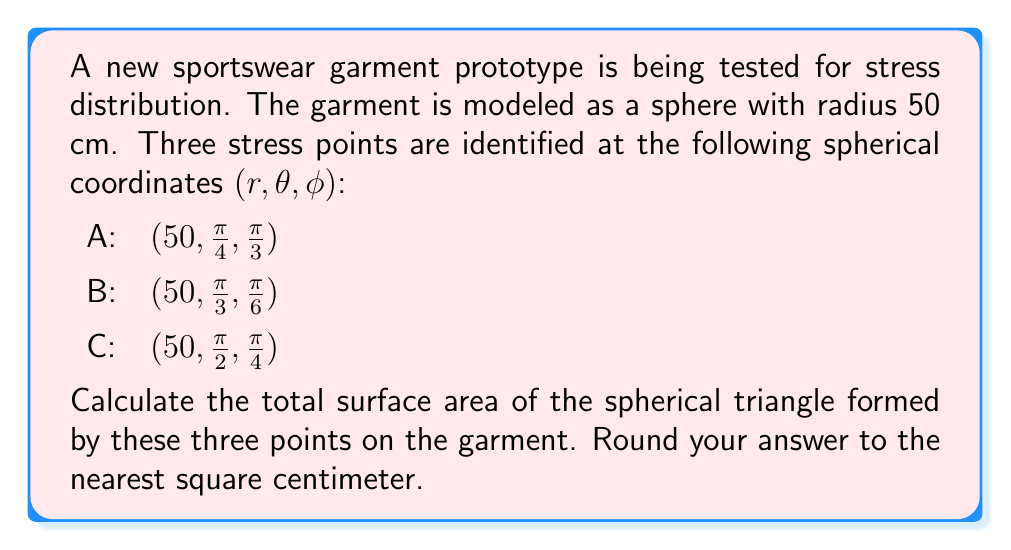Show me your answer to this math problem. To solve this problem, we'll use the following steps:

1) First, we need to calculate the angles between the points on the sphere's surface. We can do this using the spherical law of cosines:

   $$\cos(c) = \sin(a)\sin(b)\cos(C) + \cos(a)\cos(b)$$

   where $a$, $b$, and $c$ are the great circle distances between the points, and $C$ is the angle between $a$ and $b$ at the pole.

2) We can calculate $\cos(C)$ for each pair of points using:

   $$\cos(C) = \frac{\cos(c) - \cos(a)\cos(b)}{\sin(a)\sin(b)}$$

3) Once we have the angles, we can use the spherical excess formula to calculate the area:

   $$A = R^2(A + B + C - \pi)$$

   where $A$, $B$, and $C$ are the angles of the spherical triangle, and $R$ is the radius of the sphere.

4) Let's calculate the cosines of the great circle distances:

   $$\cos(AB) = \sin(\frac{\pi}{4})\sin(\frac{\pi}{3})\cos(\frac{\pi}{3}-\frac{\pi}{6}) + \cos(\frac{\pi}{4})\cos(\frac{\pi}{3})$$
   $$\cos(BC) = \sin(\frac{\pi}{3})\sin(\frac{\pi}{2})\cos(\frac{\pi}{6}-\frac{\pi}{4}) + \cos(\frac{\pi}{3})\cos(\frac{\pi}{2})$$
   $$\cos(AC) = \sin(\frac{\pi}{4})\sin(\frac{\pi}{2})\cos(\frac{\pi}{3}-\frac{\pi}{4}) + \cos(\frac{\pi}{4})\cos(\frac{\pi}{2})$$

5) Now we can calculate the angles:

   $$A = \arccos(\frac{\cos(BC) - \cos(AB)\cos(AC)}{\sin(AB)\sin(AC)})$$
   $$B = \arccos(\frac{\cos(AC) - \cos(AB)\cos(BC)}{\sin(AB)\sin(BC)})$$
   $$C = \arccos(\frac{\cos(AB) - \cos(AC)\cos(BC)}{\sin(AC)\sin(BC)})$$

6) Finally, we can calculate the area:

   $$Area = 50^2(A + B + C - \pi)$$

7) Calculating this numerically and rounding to the nearest square centimeter gives us the final answer.
Answer: The surface area of the spherical triangle is approximately 491 cm². 